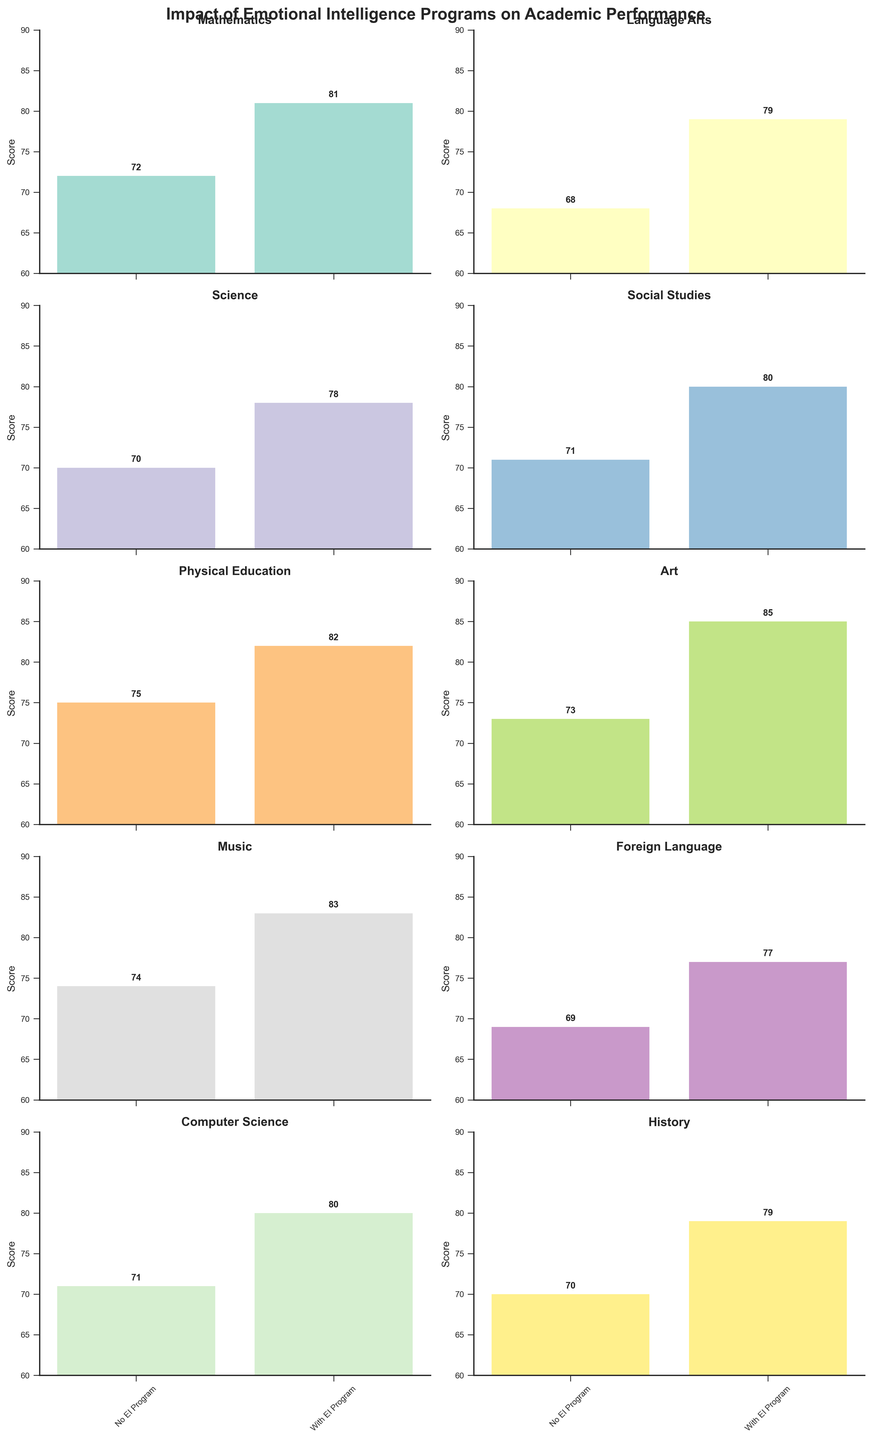Which subject shows the largest increase in scores due to the EI program? To find the subject with the largest increase in scores, calculate the difference between 'With EI Program' and 'No EI Program' for each subject, then compare the differences. Art shows an increase of 12 points (85 - 73), the largest among all subjects.
Answer: Art What's the highest score achieved with the EI Program? Review the 'With EI Program' scores across all subjects. Art has the highest score of 85.
Answer: 85 Which subject has the smallest difference in scores between 'No EI Program' and 'With EI Program'? Calculate the score difference for each subject. Physical Education and Computer Science both have the smallest increase, which is 9 (82 - 75 and 80 - 71 respectively).
Answer: Physical Education, Computer Science How many subjects have a score of 80 or above with the EI program? Count the subjects that have scores 80 or above in the 'With EI Program' category. These are Mathematics, Language Arts, Science, Social Studies, Physical Education, Art, Music, and Computer Science. There are 8 subjects.
Answer: 8 Which subject experienced the lowest score increase with the EI program? By calculating the score differences for each subject, the smallest is Physical Education and Computer Science with an increase of 7 and 9 points respectively (82 - 75).
Answer: Physical Education, Computer Science What’s the average score for subjects without the EI program? Calculate the sum of all scores for 'No EI Program' and divide it by the number of subjects: (72+68+70+71+75+73+74+69+71+70) / 10 = 71.3
Answer: 71.3 Which subjects had a score above 80 with the EI Program but below 75 without it? Identify subjects meeting the criteria: 'With EI Program' score > 80 and 'No EI Program' score < 75. Art (85, 73) and Music (83, 74) satisfy this.
Answer: Art, Music Is the improvement in Mathematics larger or in Science? Calculate the improvement: for Mathematics, it's 81 - 72 = 9; for Science, it's 78 - 70 = 8. Mathematics has a larger improvement.
Answer: Mathematics What is the total score increase across all subjects with the EI program? Calculate the total score increase: (81 - 72) + (79 - 68) + (78 - 70) + (80 - 71) + (82 - 75) + (85 - 73) + (83 - 74) + (77 - 69) + (80 - 71) + (79 - 70) = 9 + 11 + 8 + 9 + 7 + 12 + 9 + 8 + 9 + 9 = 91
Answer: 91 Does any subject have a score exactly equal to 75 without the EI program? Review scores in the 'No EI Program' column. Physical Education has a score of 75.
Answer: Yes, Physical Education 